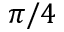<formula> <loc_0><loc_0><loc_500><loc_500>\pi / 4</formula> 